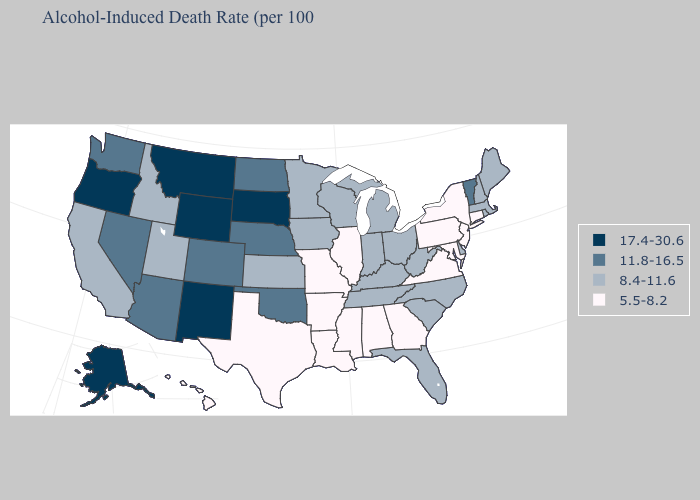What is the value of Nevada?
Answer briefly. 11.8-16.5. Does the map have missing data?
Write a very short answer. No. What is the value of Kansas?
Concise answer only. 8.4-11.6. Name the states that have a value in the range 17.4-30.6?
Short answer required. Alaska, Montana, New Mexico, Oregon, South Dakota, Wyoming. Does the map have missing data?
Keep it brief. No. Among the states that border Wyoming , does Idaho have the lowest value?
Write a very short answer. Yes. Which states hav the highest value in the Northeast?
Quick response, please. Vermont. What is the value of New Mexico?
Give a very brief answer. 17.4-30.6. Name the states that have a value in the range 11.8-16.5?
Be succinct. Arizona, Colorado, Nebraska, Nevada, North Dakota, Oklahoma, Vermont, Washington. Name the states that have a value in the range 11.8-16.5?
Short answer required. Arizona, Colorado, Nebraska, Nevada, North Dakota, Oklahoma, Vermont, Washington. Among the states that border Missouri , does Illinois have the lowest value?
Write a very short answer. Yes. Name the states that have a value in the range 8.4-11.6?
Write a very short answer. California, Delaware, Florida, Idaho, Indiana, Iowa, Kansas, Kentucky, Maine, Massachusetts, Michigan, Minnesota, New Hampshire, North Carolina, Ohio, Rhode Island, South Carolina, Tennessee, Utah, West Virginia, Wisconsin. What is the value of Illinois?
Short answer required. 5.5-8.2. What is the highest value in states that border Nevada?
Concise answer only. 17.4-30.6. What is the value of Kansas?
Concise answer only. 8.4-11.6. 